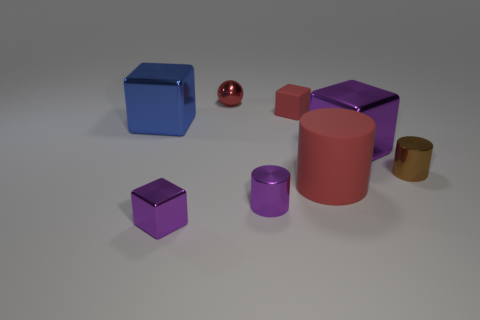Add 1 brown cylinders. How many objects exist? 9 Subtract all cylinders. How many objects are left? 5 Subtract 0 purple balls. How many objects are left? 8 Subtract all tiny shiny cubes. Subtract all small objects. How many objects are left? 2 Add 7 tiny cylinders. How many tiny cylinders are left? 9 Add 6 small blue matte cylinders. How many small blue matte cylinders exist? 6 